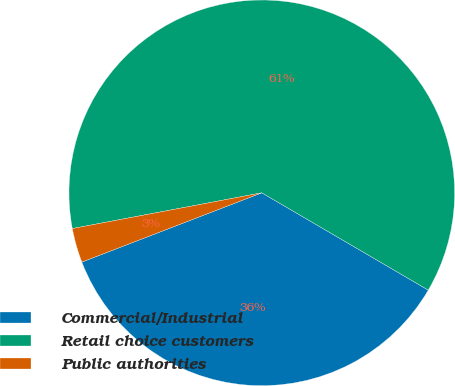Convert chart. <chart><loc_0><loc_0><loc_500><loc_500><pie_chart><fcel>Commercial/Industrial<fcel>Retail choice customers<fcel>Public authorities<nl><fcel>35.73%<fcel>61.38%<fcel>2.88%<nl></chart> 